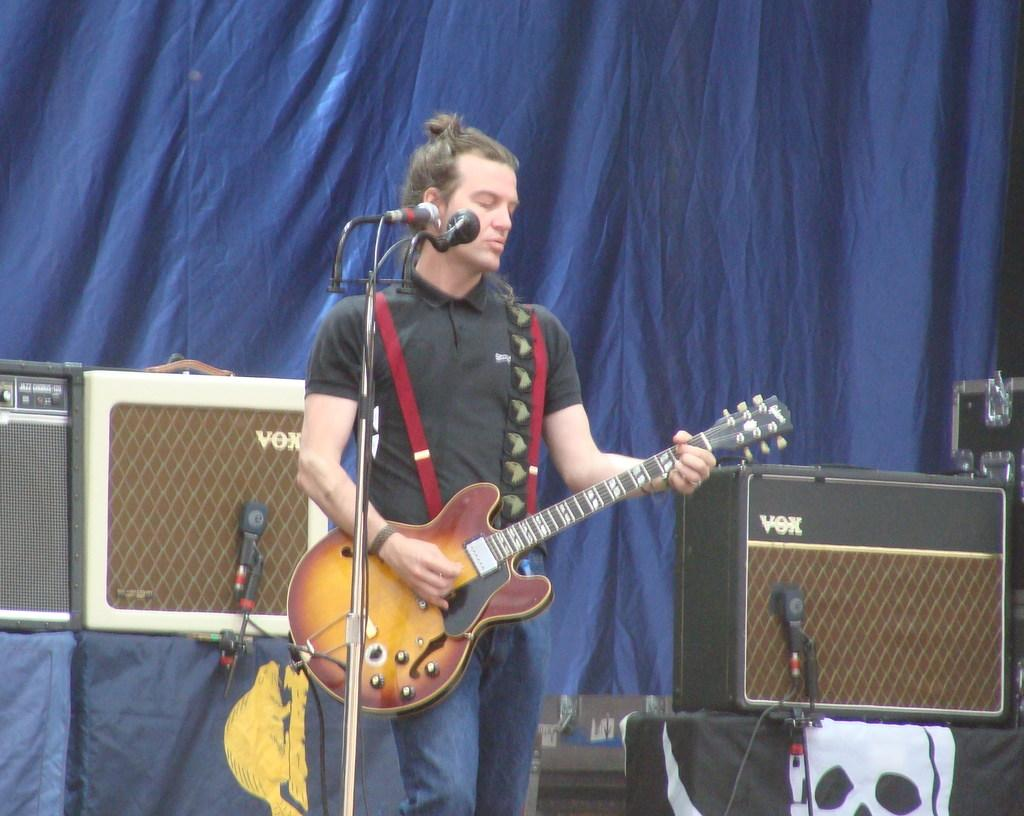What is the man in the image doing? The man is standing, playing a guitar, singing a song, and using a microphone. What instrument is the man playing in the image? The man is playing a guitar in the image. What device is the man using to amplify his voice? The man is using a microphone in the image. What additional equipment can be seen in the image? There are sound boxes visible in the image. What color cloth is present in the image? There is a blue color cloth in the image. How many thumbs does the man have on his left hand in the image? The image does not provide information about the number of thumbs the man has on his left hand. What type of birds can be seen flying in the image? There are no birds visible in the image. 